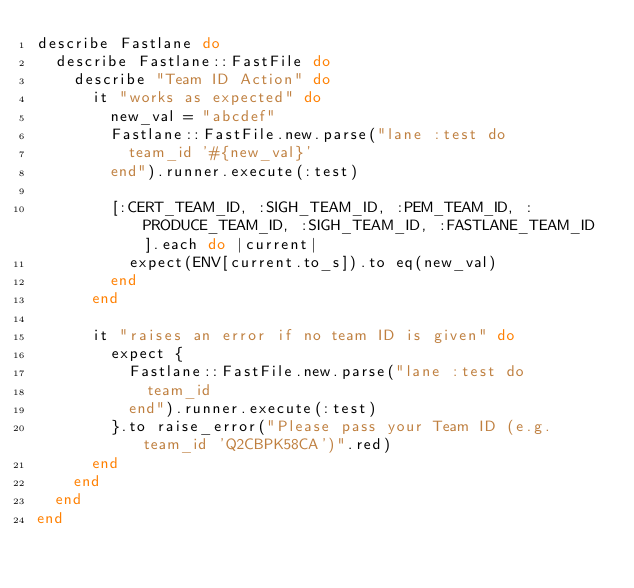<code> <loc_0><loc_0><loc_500><loc_500><_Ruby_>describe Fastlane do
  describe Fastlane::FastFile do
    describe "Team ID Action" do
      it "works as expected" do
        new_val = "abcdef"
        Fastlane::FastFile.new.parse("lane :test do 
          team_id '#{new_val}'
        end").runner.execute(:test)

        [:CERT_TEAM_ID, :SIGH_TEAM_ID, :PEM_TEAM_ID, :PRODUCE_TEAM_ID, :SIGH_TEAM_ID, :FASTLANE_TEAM_ID].each do |current|
          expect(ENV[current.to_s]).to eq(new_val)
        end
      end

      it "raises an error if no team ID is given" do
        expect {
          Fastlane::FastFile.new.parse("lane :test do 
            team_id
          end").runner.execute(:test)
        }.to raise_error("Please pass your Team ID (e.g. team_id 'Q2CBPK58CA')".red)
      end
    end
  end
end
</code> 